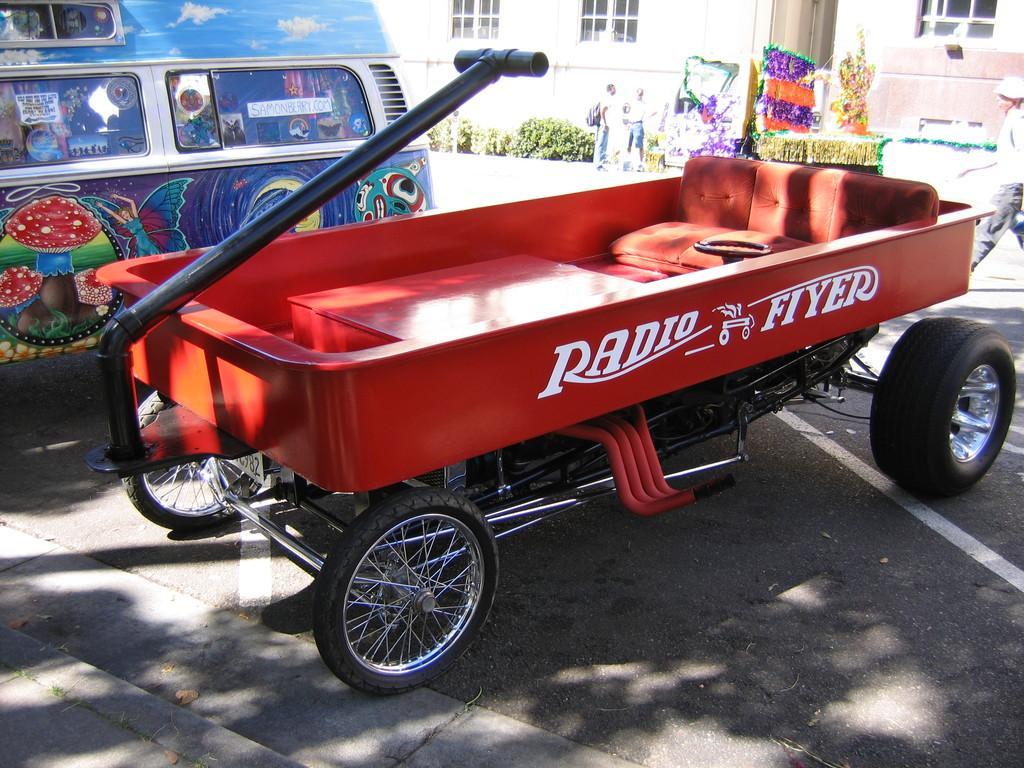Can you describe this image briefly? In the background we can see the wall, windows, plants, objects and people. In this picture we can see vehicles. On the right side of the picture looks like a person is walking. At the bottom portion of the picture we can see the road. 